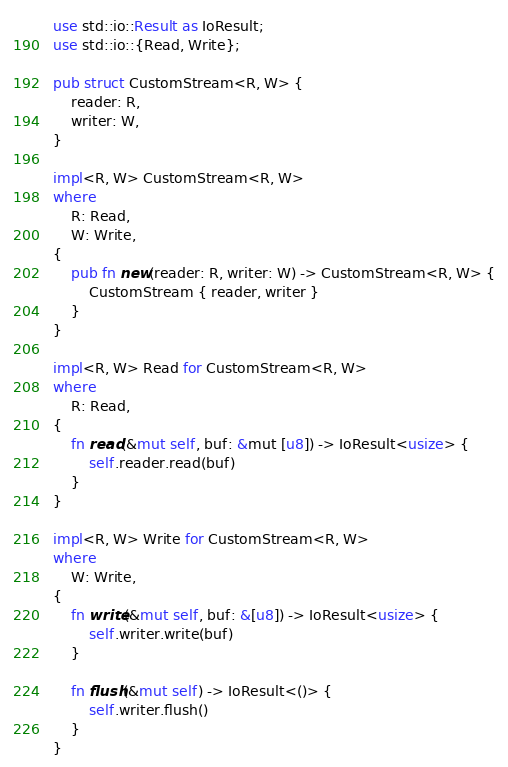<code> <loc_0><loc_0><loc_500><loc_500><_Rust_>use std::io::Result as IoResult;
use std::io::{Read, Write};

pub struct CustomStream<R, W> {
    reader: R,
    writer: W,
}

impl<R, W> CustomStream<R, W>
where
    R: Read,
    W: Write,
{
    pub fn new(reader: R, writer: W) -> CustomStream<R, W> {
        CustomStream { reader, writer }
    }
}

impl<R, W> Read for CustomStream<R, W>
where
    R: Read,
{
    fn read(&mut self, buf: &mut [u8]) -> IoResult<usize> {
        self.reader.read(buf)
    }
}

impl<R, W> Write for CustomStream<R, W>
where
    W: Write,
{
    fn write(&mut self, buf: &[u8]) -> IoResult<usize> {
        self.writer.write(buf)
    }

    fn flush(&mut self) -> IoResult<()> {
        self.writer.flush()
    }
}
</code> 